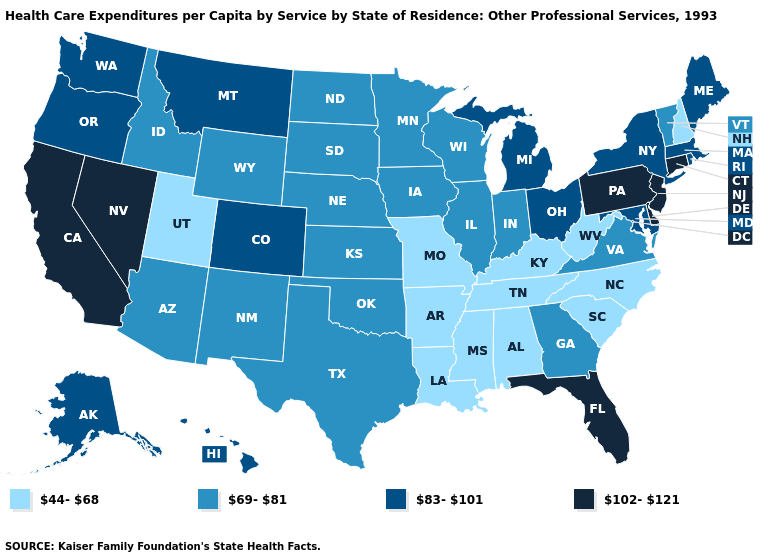What is the lowest value in the Northeast?
Give a very brief answer. 44-68. Among the states that border Arizona , which have the highest value?
Concise answer only. California, Nevada. What is the value of Massachusetts?
Concise answer only. 83-101. Does the map have missing data?
Quick response, please. No. Which states have the highest value in the USA?
Be succinct. California, Connecticut, Delaware, Florida, Nevada, New Jersey, Pennsylvania. What is the value of South Carolina?
Quick response, please. 44-68. Name the states that have a value in the range 69-81?
Keep it brief. Arizona, Georgia, Idaho, Illinois, Indiana, Iowa, Kansas, Minnesota, Nebraska, New Mexico, North Dakota, Oklahoma, South Dakota, Texas, Vermont, Virginia, Wisconsin, Wyoming. What is the value of Kansas?
Answer briefly. 69-81. Does Wisconsin have a higher value than Arkansas?
Quick response, please. Yes. Name the states that have a value in the range 44-68?
Concise answer only. Alabama, Arkansas, Kentucky, Louisiana, Mississippi, Missouri, New Hampshire, North Carolina, South Carolina, Tennessee, Utah, West Virginia. Name the states that have a value in the range 44-68?
Be succinct. Alabama, Arkansas, Kentucky, Louisiana, Mississippi, Missouri, New Hampshire, North Carolina, South Carolina, Tennessee, Utah, West Virginia. Which states have the lowest value in the USA?
Short answer required. Alabama, Arkansas, Kentucky, Louisiana, Mississippi, Missouri, New Hampshire, North Carolina, South Carolina, Tennessee, Utah, West Virginia. What is the highest value in the USA?
Quick response, please. 102-121. Does Texas have a higher value than Kentucky?
Quick response, please. Yes. Among the states that border Wisconsin , which have the highest value?
Answer briefly. Michigan. 